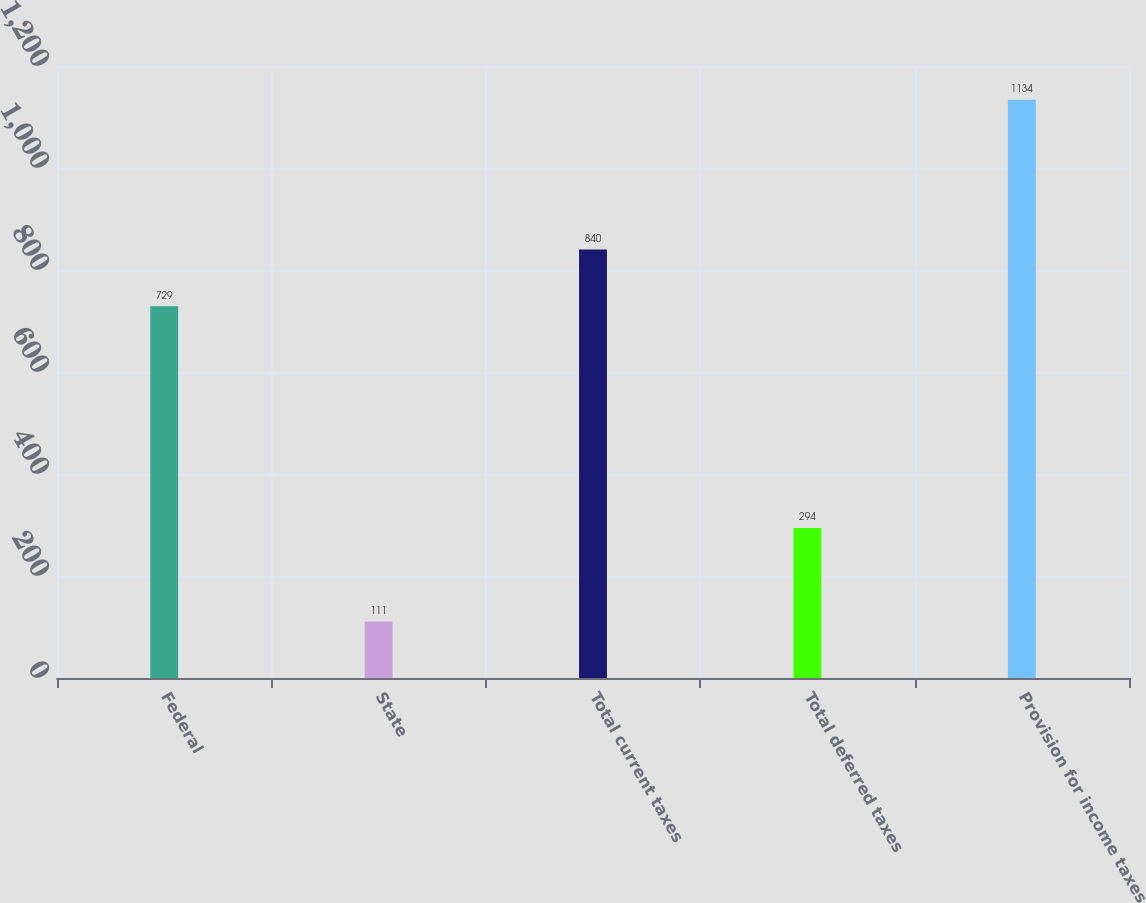<chart> <loc_0><loc_0><loc_500><loc_500><bar_chart><fcel>Federal<fcel>State<fcel>Total current taxes<fcel>Total deferred taxes<fcel>Provision for income taxes<nl><fcel>729<fcel>111<fcel>840<fcel>294<fcel>1134<nl></chart> 